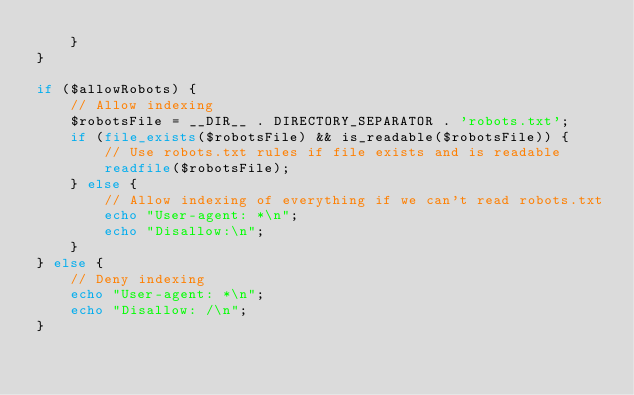Convert code to text. <code><loc_0><loc_0><loc_500><loc_500><_PHP_>    }
}

if ($allowRobots) {
    // Allow indexing
    $robotsFile = __DIR__ . DIRECTORY_SEPARATOR . 'robots.txt';
    if (file_exists($robotsFile) && is_readable($robotsFile)) {
        // Use robots.txt rules if file exists and is readable
        readfile($robotsFile);
    } else {
        // Allow indexing of everything if we can't read robots.txt
        echo "User-agent: *\n";
        echo "Disallow:\n";
    }
} else {
    // Deny indexing
    echo "User-agent: *\n";
    echo "Disallow: /\n";
}
</code> 